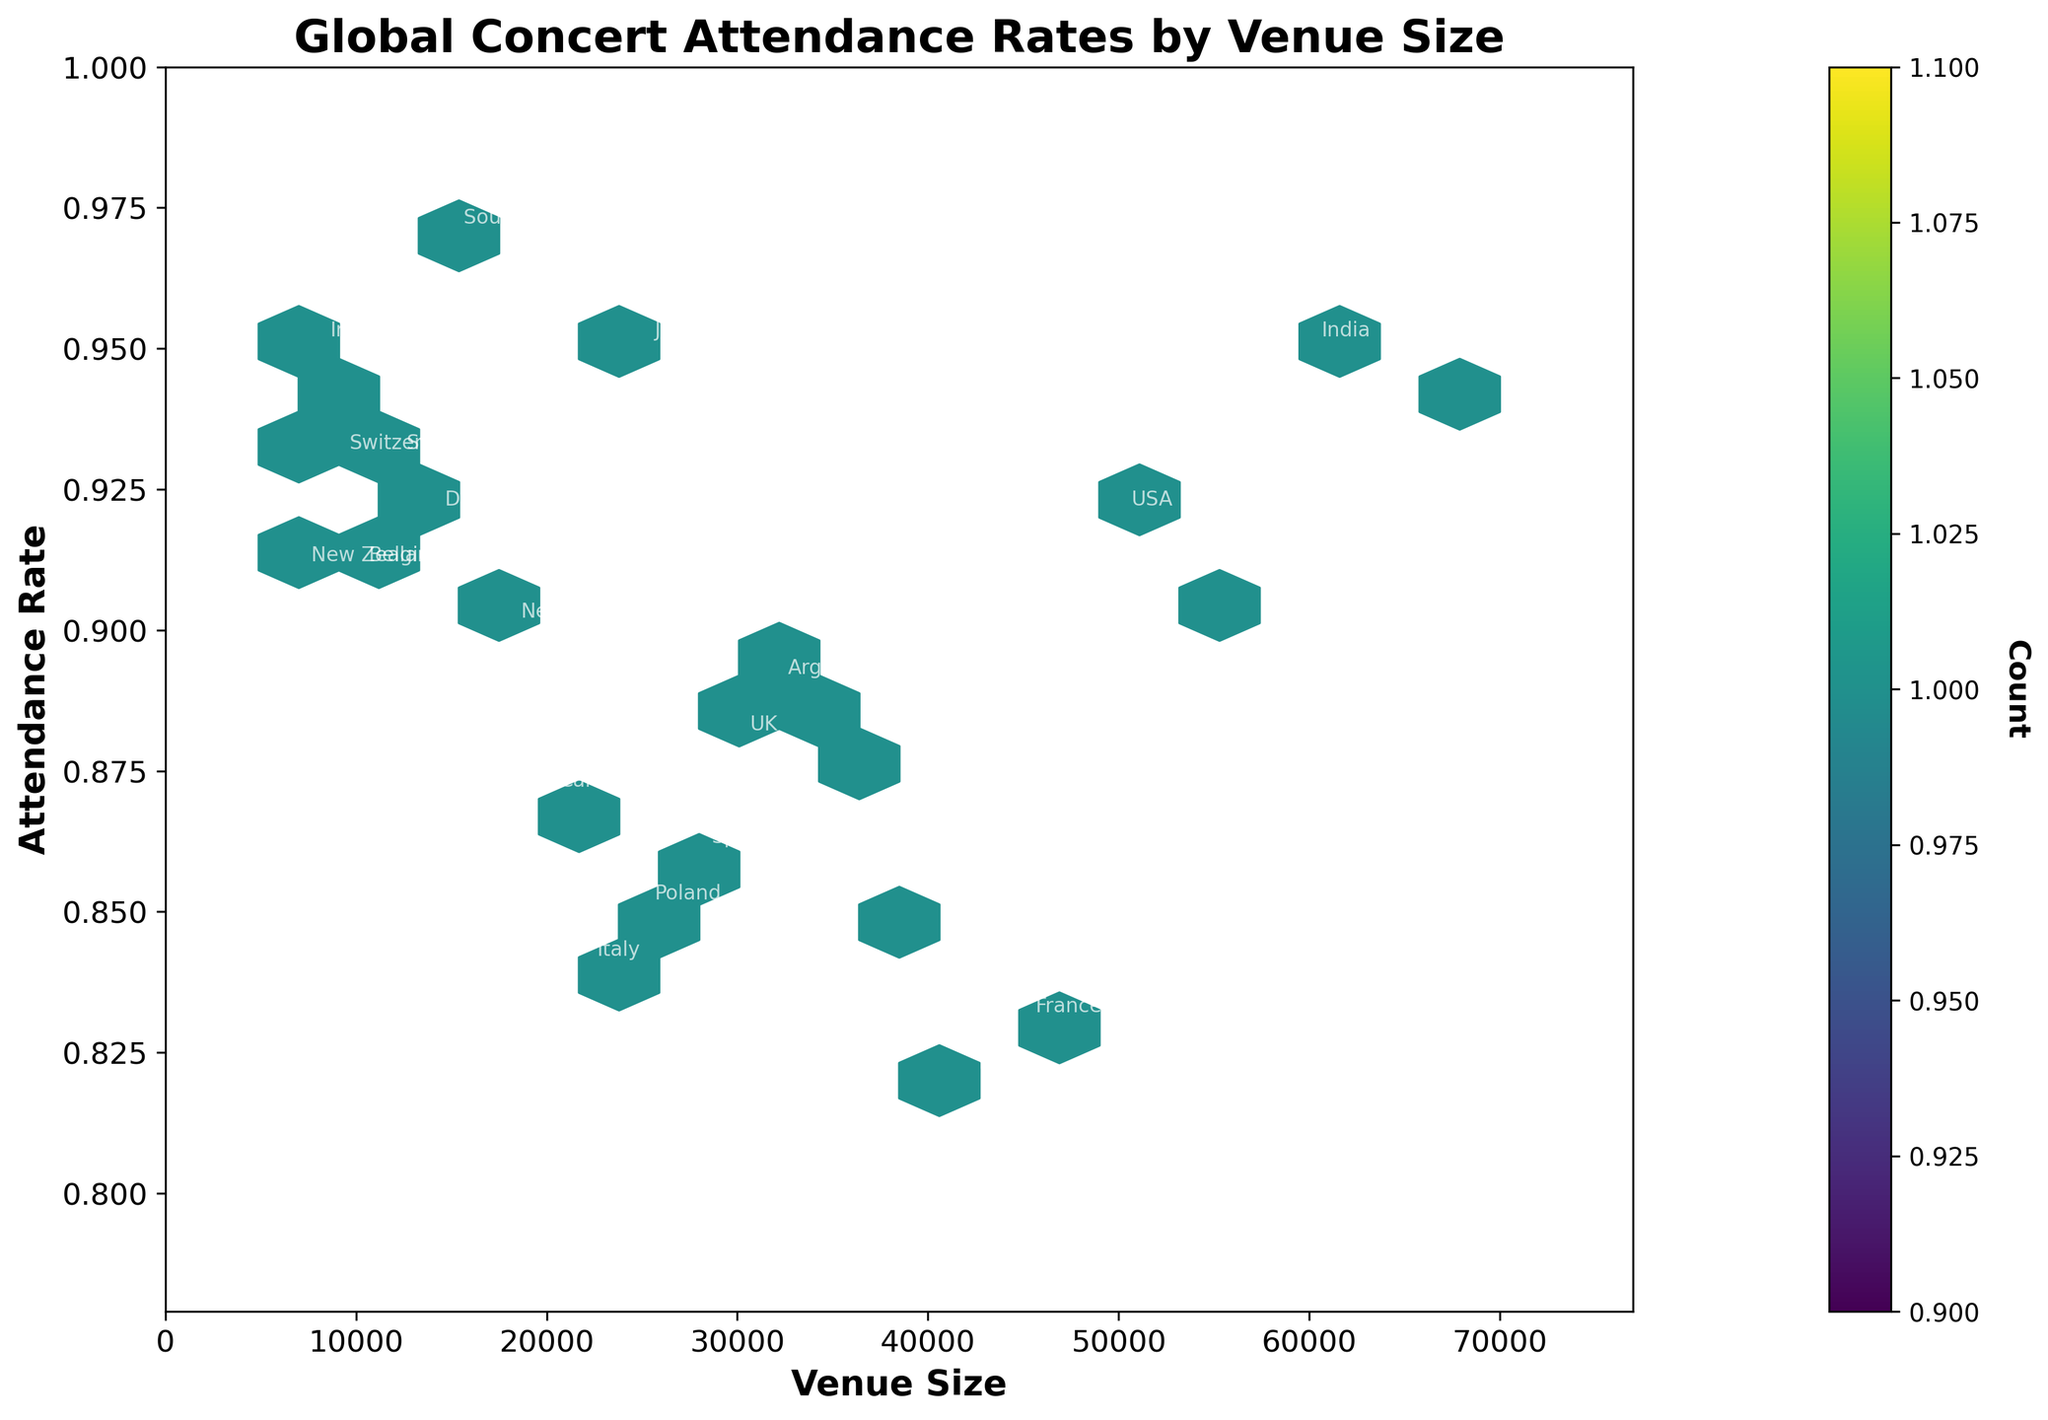What's the title of the figure? By reading the title at the top of the figure, the information is directly stated.
Answer: Global Concert Attendance Rates by Venue Size What's the range of venue sizes presented in the figure? By observing the x-axis, we see the smallest value is approximately 0 and the largest value is around 70000.
Answer: 0 to 70000 Which country has the highest attendance rate? By checking the y-axis for the highest attendance rate value and the corresponding label, we find it's South Korea with 0.97.
Answer: South Korea What's the color gradient used in the plot, and what does it represent? The color gradient goes from blue to yellow, representing the density of data points in each hexbin.
Answer: Density of data points How many countries have attendance rates above 0.90? By counting the number of labeled points above the 0.90 mark on the y-axis, we notice the following countries: USA, Japan, India, South Korea, China, Sweden, Switzerland, Belgium, Ireland, and Norway.
Answer: 10 Which country has the largest venue size, and what is its attendance rate? By finding the point with the largest x-axis value and reading both its label and y-axis value, we identify China with an attendance rate of 0.94.
Answer: China, 0.94 Compare the attendance rates of Australia and Brazil. Which country has a higher rate, and by how much? Australia's rate is 0.89 and Brazil's rate is 0.91. Subtracting the two, Brazil's rate is higher by 0.02.
Answer: Brazil, 0.02 What's the average attendance rate for countries with venue sizes between 20000 and 30000? Countries: UK (0.88), Japan (0.95), Canada (0.87), Spain (0.86), Italy (0.84). Sum: 0.88 + 0.95 + 0.87 + 0.86 + 0.84 = 4.4. Average: 4.4 / 5 = 0.88
Answer: 0.88 Identify any outliers in terms of low attendance rates. Which country stands out and what is its attendance rate? By examining the points near the lower end of the y-axis values, Russia with an attendance rate of 0.82 stands out.
Answer: Russia, 0.82 Are there more countries with attendance rates above or below 0.90? How many in each category? Counting the points above 0.90 gives 10 countries. Counting below shows 15 countries. Deciphering from the y-axis labels assists in this count.
Answer: Above: 10, Below: 15 